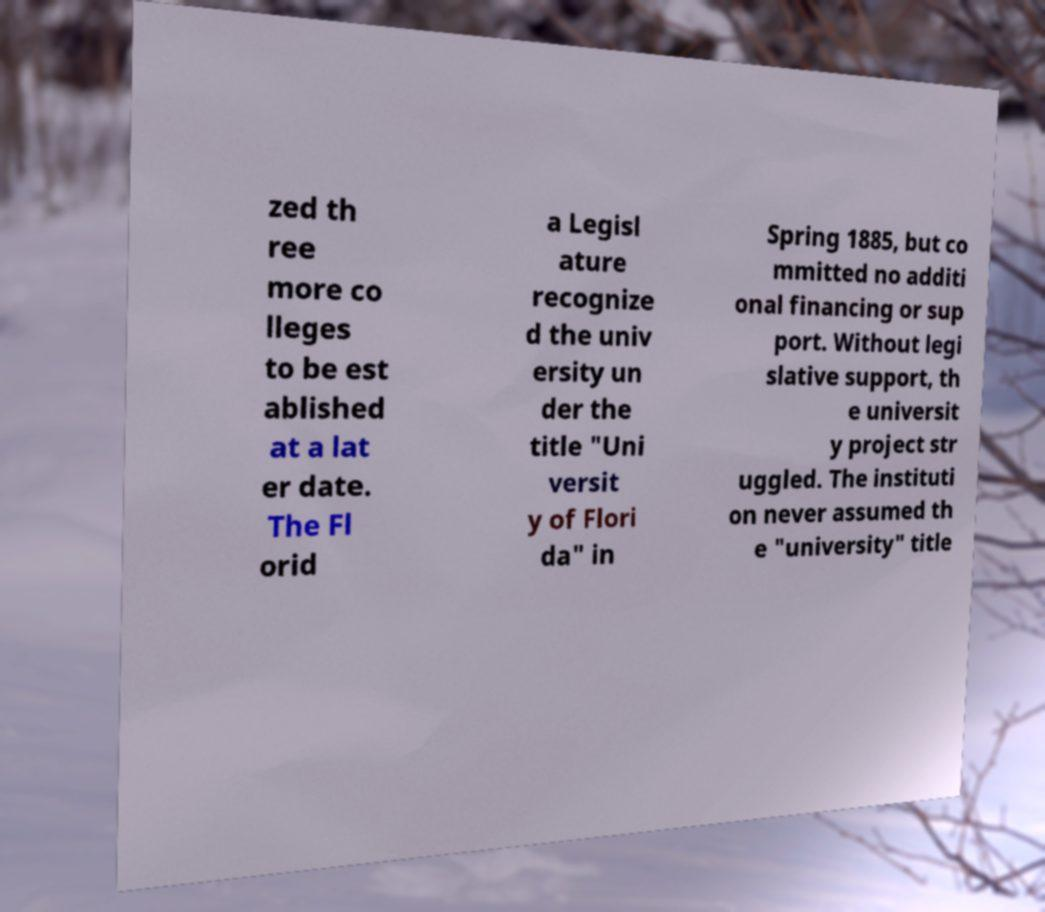Can you read and provide the text displayed in the image?This photo seems to have some interesting text. Can you extract and type it out for me? zed th ree more co lleges to be est ablished at a lat er date. The Fl orid a Legisl ature recognize d the univ ersity un der the title "Uni versit y of Flori da" in Spring 1885, but co mmitted no additi onal financing or sup port. Without legi slative support, th e universit y project str uggled. The instituti on never assumed th e "university" title 